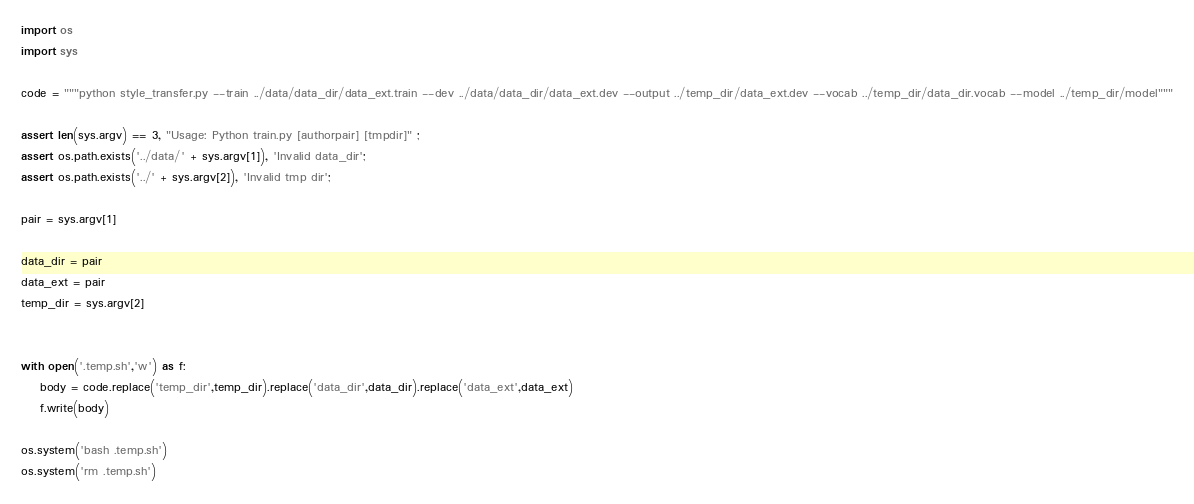<code> <loc_0><loc_0><loc_500><loc_500><_Python_>import os
import sys

code = """python style_transfer.py --train ../data/data_dir/data_ext.train --dev ../data/data_dir/data_ext.dev --output ../temp_dir/data_ext.dev --vocab ../temp_dir/data_dir.vocab --model ../temp_dir/model"""

assert len(sys.argv) == 3, "Usage: Python train.py [authorpair] [tmpdir]" ;
assert os.path.exists('../data/' + sys.argv[1]), 'Invalid data_dir';
assert os.path.exists('../' + sys.argv[2]), 'Invalid tmp dir';

pair = sys.argv[1]

data_dir = pair
data_ext = pair
temp_dir = sys.argv[2]


with open('.temp.sh','w') as f:
    body = code.replace('temp_dir',temp_dir).replace('data_dir',data_dir).replace('data_ext',data_ext)
    f.write(body)

os.system('bash .temp.sh')
os.system('rm .temp.sh')
</code> 